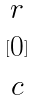<formula> <loc_0><loc_0><loc_500><loc_500>[ \begin{matrix} r \\ 0 \\ c \end{matrix} ]</formula> 